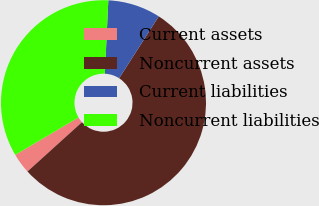<chart> <loc_0><loc_0><loc_500><loc_500><pie_chart><fcel>Current assets<fcel>Noncurrent assets<fcel>Current liabilities<fcel>Noncurrent liabilities<nl><fcel>3.21%<fcel>54.23%<fcel>8.31%<fcel>34.24%<nl></chart> 